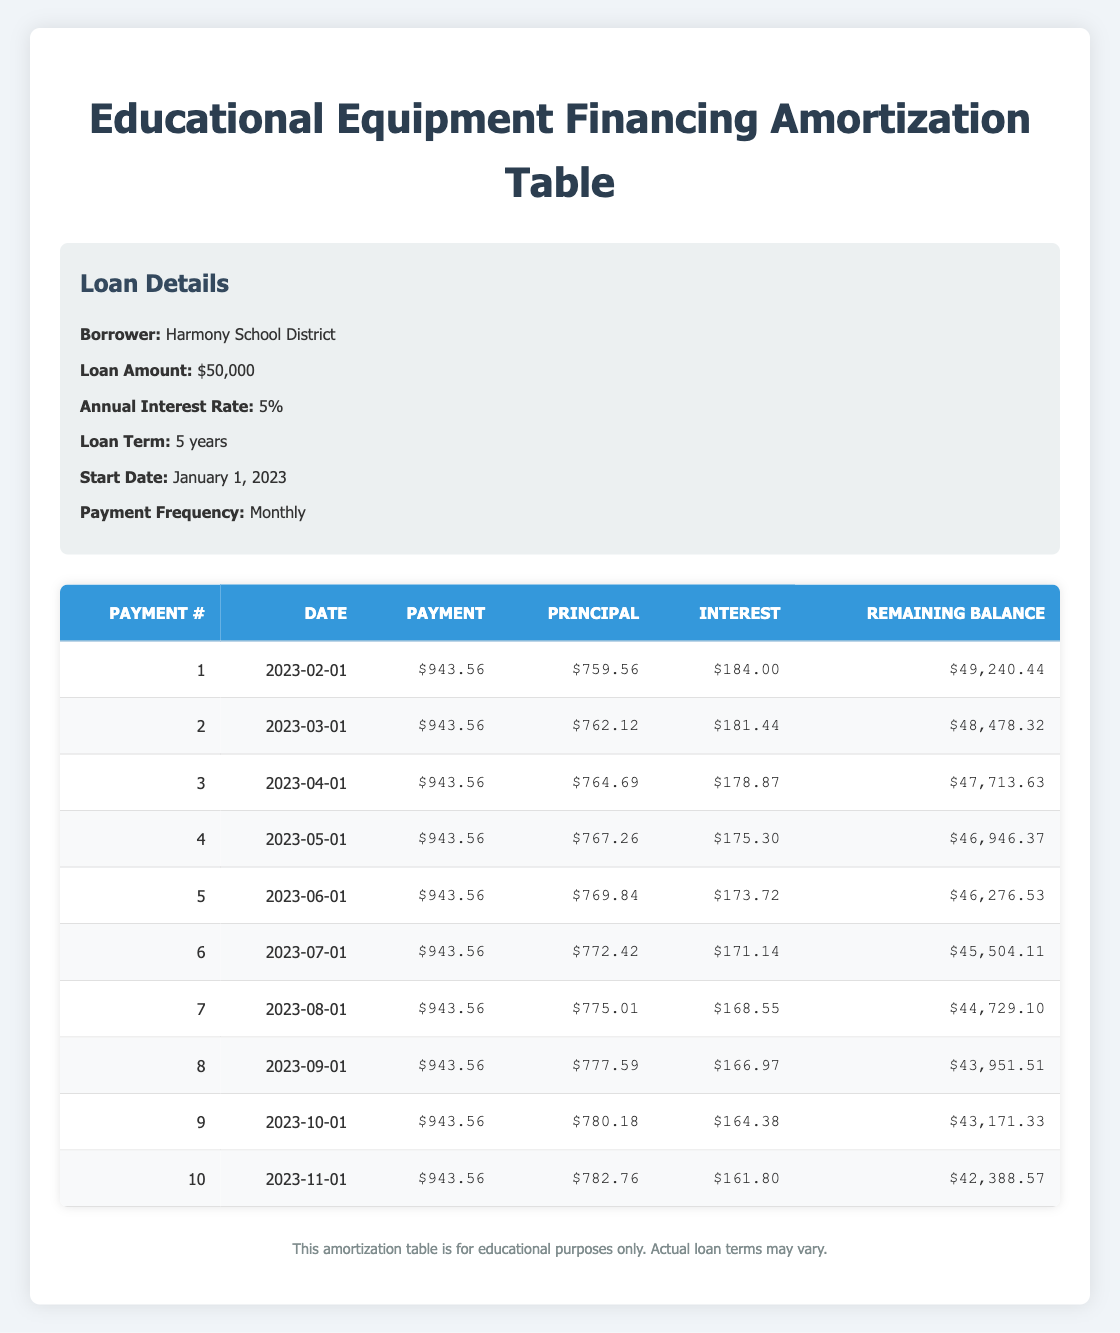What is the total amount of payments made after the first five months? To find the total amount paid in the first five months, we sum the payment amounts for payments 1 through 5. The payments are all $943.56, so we calculate: 5 x 943.56 = 4717.80.
Answer: 4717.80 What was the principal payment in the second month? The principal payment for the second month, which is the value in the principal payment column for payment number 2, is $762.12.
Answer: 762.12 Is the interest payment in the third month higher than in the first month? The interest payment in the first month is $184.00, and in the third month, it is $178.87. Since $184.00 is greater than $178.87, the statement is true.
Answer: Yes What is the remaining balance after the sixth payment? The remaining balance after the sixth payment is directly noted in the table under the remaining balance column for payment number 6, which is $45,504.11.
Answer: 45,504.11 What is the total interest paid in the first three months? We calculate the total interest paid in the first three months by adding the interest payments for each month: 184.00 (month 1) + 181.44 (month 2) + 178.87 (month 3) = 544.31. Thus, the total interest paid is $544.31.
Answer: 544.31 How much more principal was paid in the tenth payment compared to the first payment? The principal payment in the tenth payment is $782.76, and in the first payment, it is $759.56. We find the difference: 782.76 - 759.56 = 23.20. Therefore, $23.20 more principal was paid in the tenth payment.
Answer: 23.20 What was the monthly payment amount? The monthly payment amount is indicated in each row as $943.56, consistently for all payments.
Answer: 943.56 Which month had the lowest interest payment, and what was that amount? Looking at the interest payment column, the lowest value is $161.80 in the tenth month (November). Thus, November had the lowest interest payment of $161.80.
Answer: 161.80 What is the total remaining balance after ten payments? The remaining balance after ten payments is shown in the table as $42,388.57 for payment number 10. This is the total remaining balance after making all ten payments.
Answer: 42,388.57 